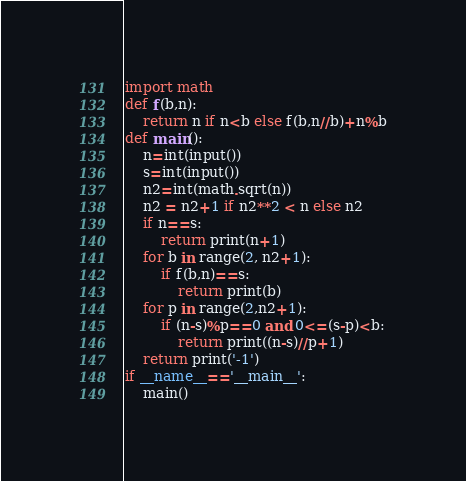<code> <loc_0><loc_0><loc_500><loc_500><_Python_>import math
def f(b,n):
    return n if n<b else f(b,n//b)+n%b
def main():
    n=int(input())
    s=int(input())
    n2=int(math.sqrt(n))
    n2 = n2+1 if n2**2 < n else n2
    if n==s:
        return print(n+1)
    for b in range(2, n2+1):
        if f(b,n)==s:
            return print(b)
    for p in range(2,n2+1):
        if (n-s)%p==0 and 0<=(s-p)<b:
            return print((n-s)//p+1)
    return print('-1')
if __name__=='__main__':
    main()
</code> 